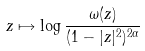Convert formula to latex. <formula><loc_0><loc_0><loc_500><loc_500>z \mapsto \log \frac { \omega ( z ) } { ( 1 - | z | ^ { 2 } ) ^ { 2 \alpha } }</formula> 